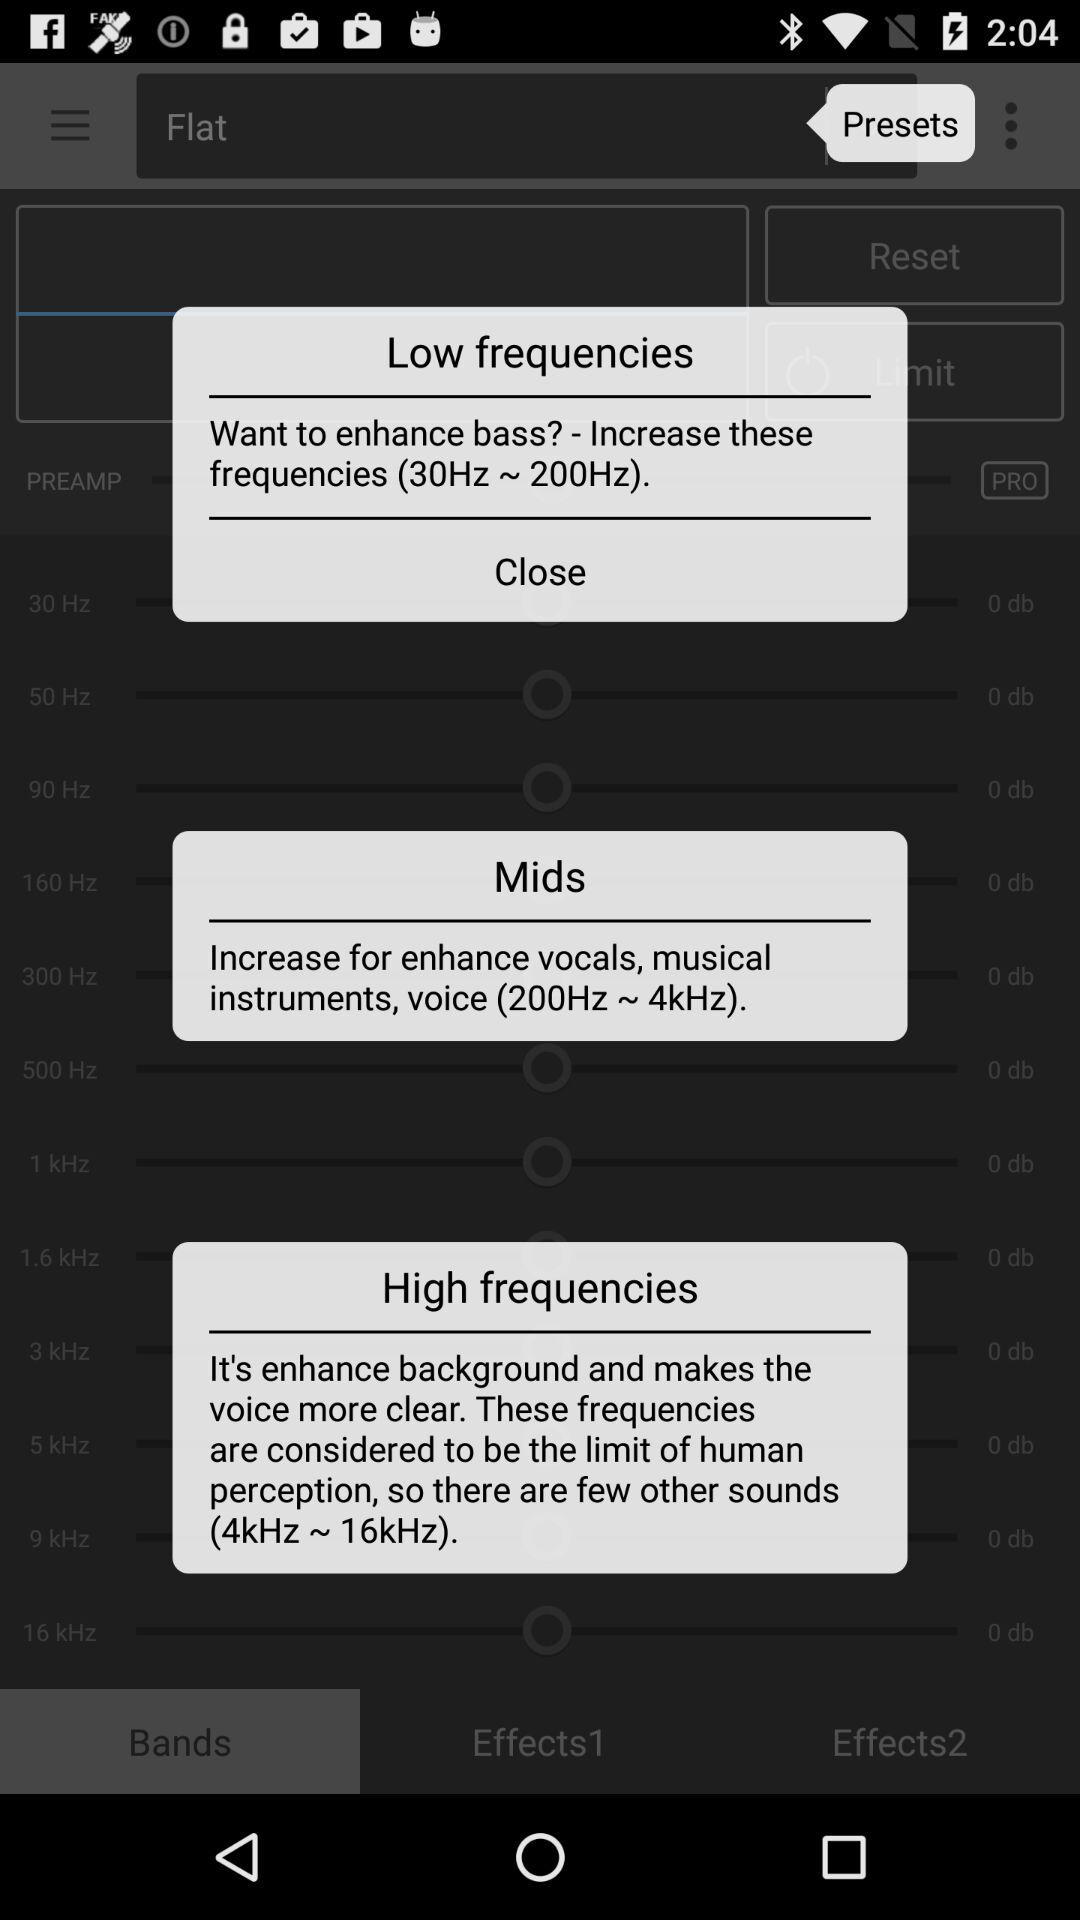How many frequencies are there on the screen?
Answer the question using a single word or phrase. 3 